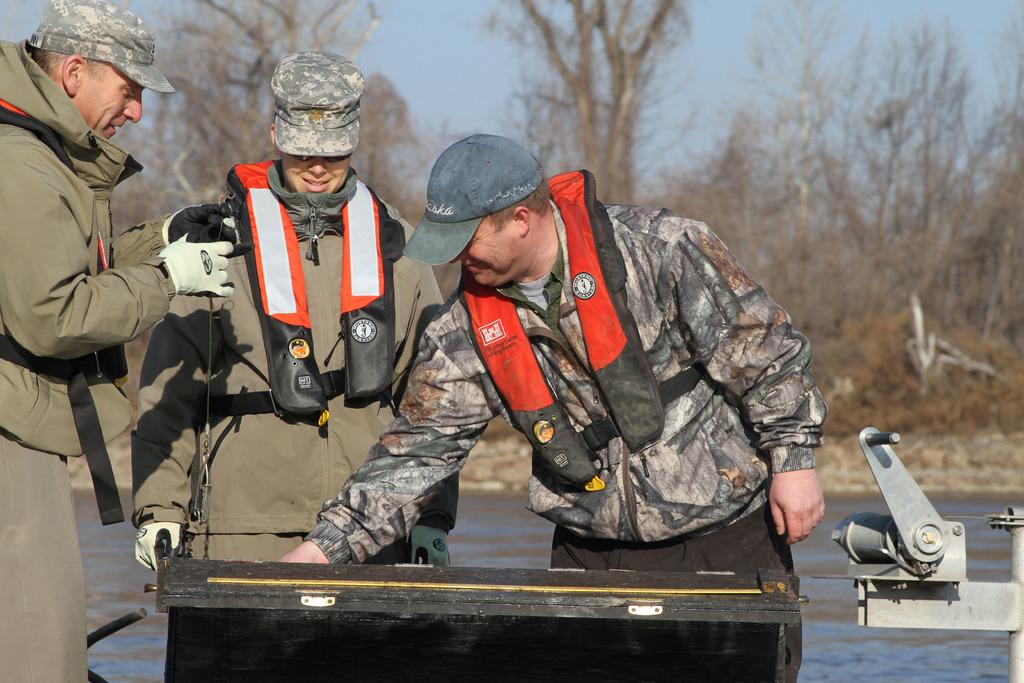How many people are in the image? There are three men in the image. What are the men wearing on their heads? The men are wearing caps. What can be seen in the background of the image? There is water and trees visible in the background of the image. What type of wrench is the man holding in the image? There is no wrench present in the image; the men are wearing caps and there are trees and water visible in the background. 